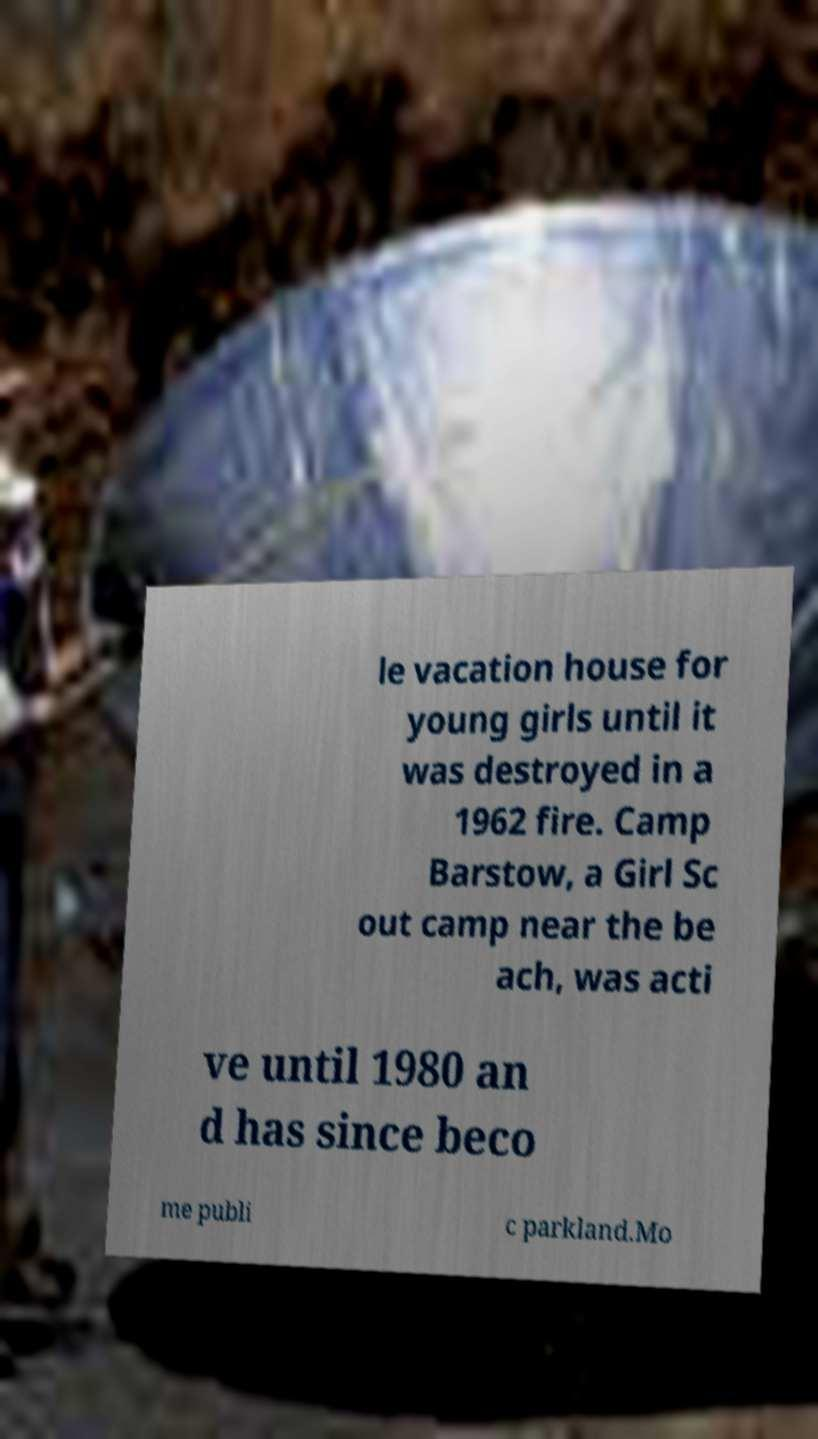I need the written content from this picture converted into text. Can you do that? le vacation house for young girls until it was destroyed in a 1962 fire. Camp Barstow, a Girl Sc out camp near the be ach, was acti ve until 1980 an d has since beco me publi c parkland.Mo 